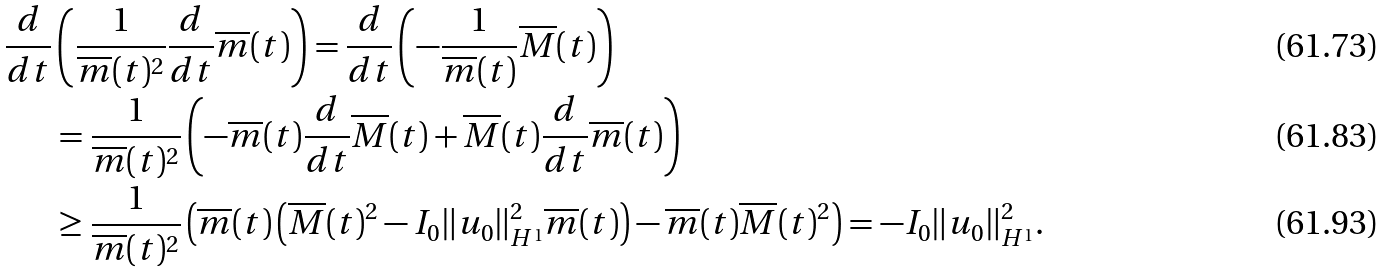<formula> <loc_0><loc_0><loc_500><loc_500>\frac { d } { d t } & \left ( \frac { 1 } { \overline { m } ( t ) ^ { 2 } } \frac { d } { d t } \overline { m } ( t ) \right ) = \frac { d } { d t } \left ( - \frac { 1 } { \overline { m } ( t ) } \overline { M } ( t ) \right ) \\ & = \frac { 1 } { \overline { m } ( t ) ^ { 2 } } \left ( - \overline { m } ( t ) \frac { d } { d t } \overline { M } ( t ) + \overline { M } ( t ) \frac { d } { d t } \overline { m } ( t ) \right ) \\ & \geq \frac { 1 } { \overline { m } ( t ) ^ { 2 } } \left ( \overline { m } ( t ) \left ( \overline { M } ( t ) ^ { 2 } - I _ { 0 } \| u _ { 0 } \| _ { H ^ { 1 } } ^ { 2 } \overline { m } ( t ) \right ) - \overline { m } ( t ) \overline { M } ( t ) ^ { 2 } \right ) = - I _ { 0 } \| u _ { 0 } \| _ { H ^ { 1 } } ^ { 2 } .</formula> 